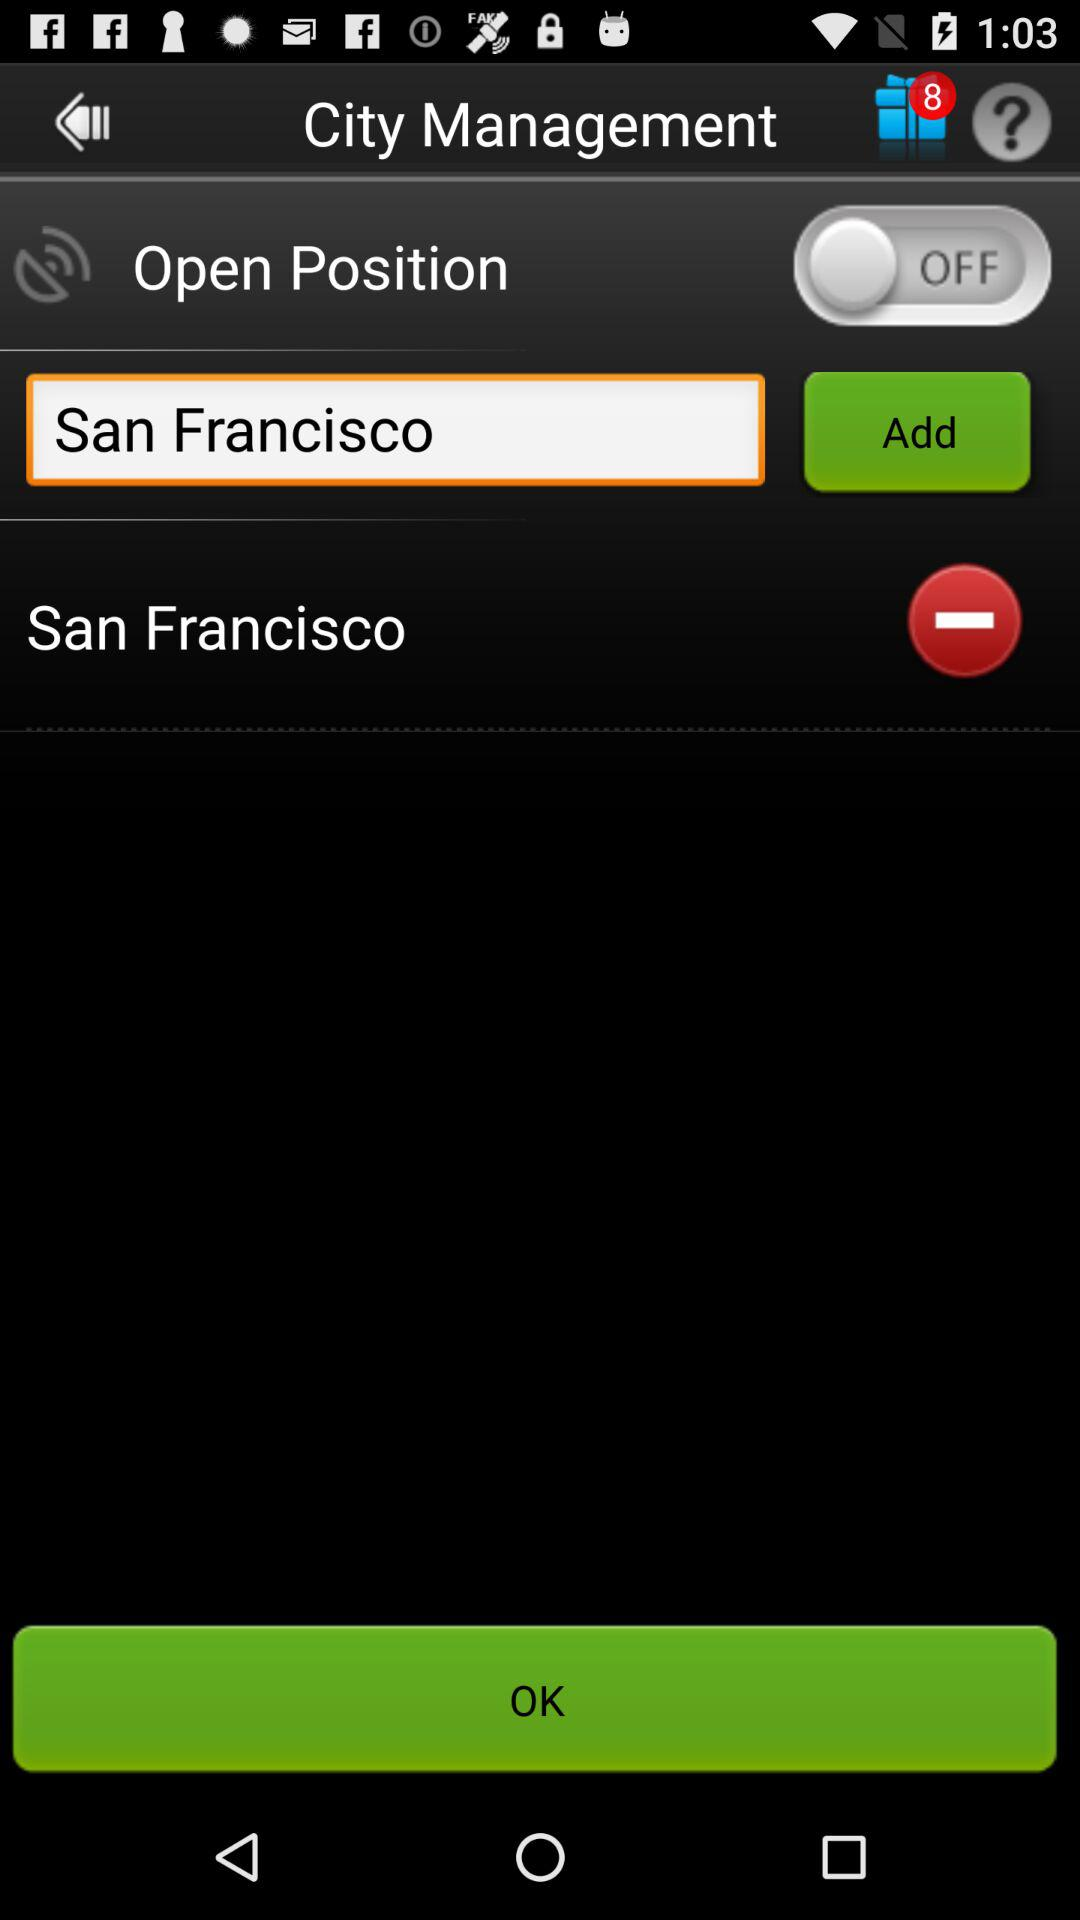What city is added? The added city is San Francisco. 